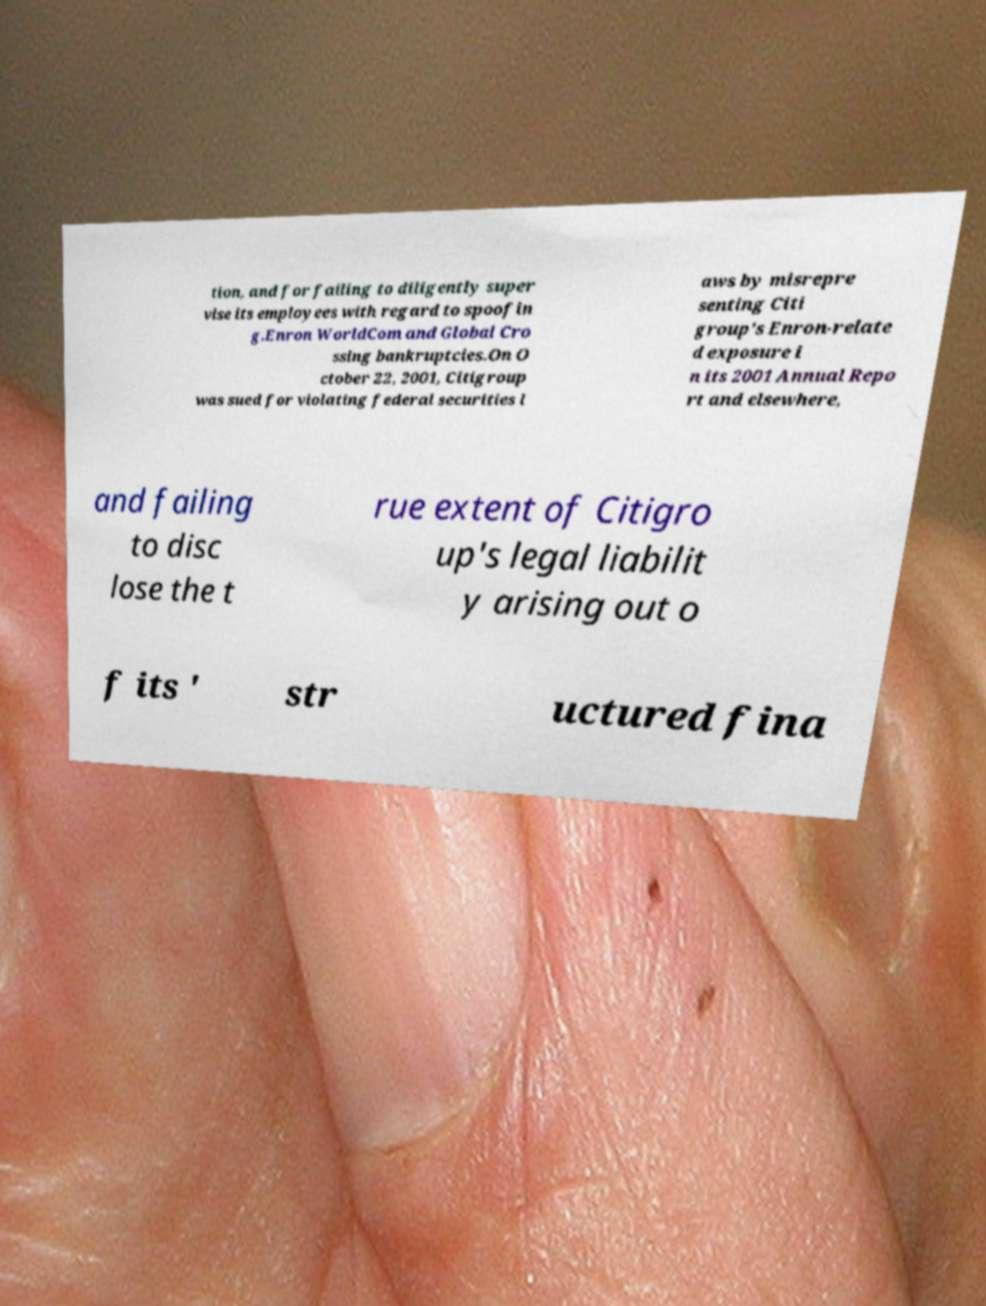I need the written content from this picture converted into text. Can you do that? tion, and for failing to diligently super vise its employees with regard to spoofin g.Enron WorldCom and Global Cro ssing bankruptcies.On O ctober 22, 2001, Citigroup was sued for violating federal securities l aws by misrepre senting Citi group's Enron-relate d exposure i n its 2001 Annual Repo rt and elsewhere, and failing to disc lose the t rue extent of Citigro up's legal liabilit y arising out o f its ' str uctured fina 